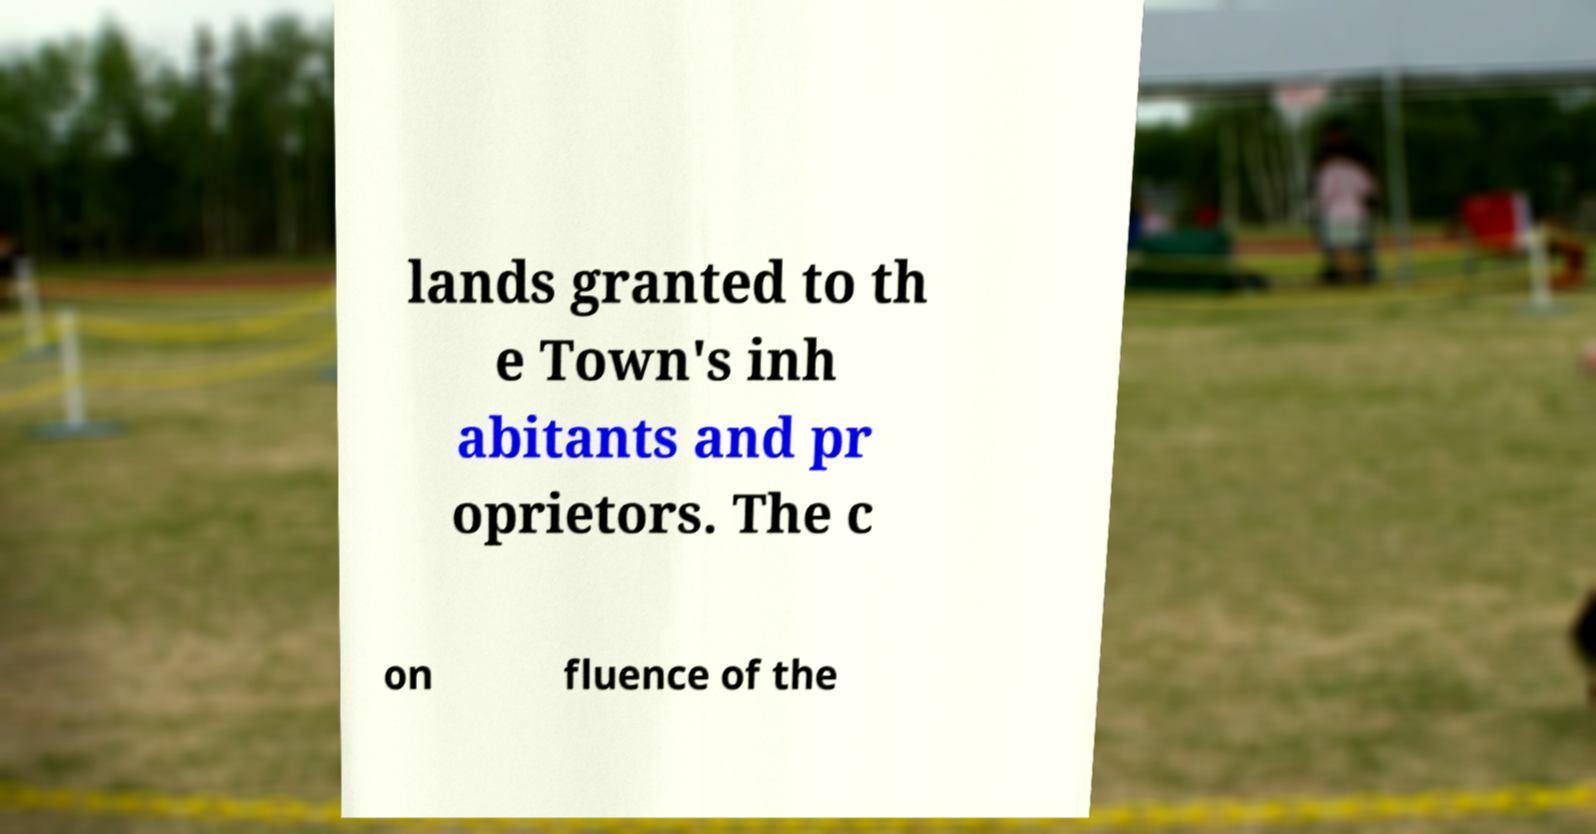Please identify and transcribe the text found in this image. lands granted to th e Town's inh abitants and pr oprietors. The c on fluence of the 